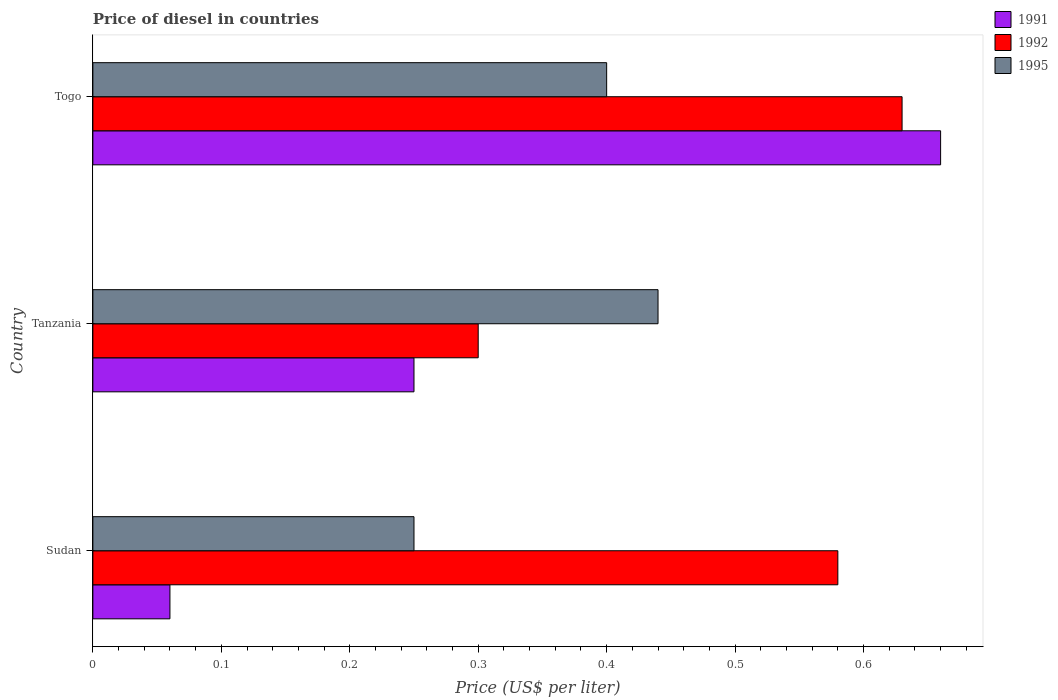What is the label of the 1st group of bars from the top?
Offer a very short reply. Togo. In how many cases, is the number of bars for a given country not equal to the number of legend labels?
Keep it short and to the point. 0. What is the price of diesel in 1992 in Sudan?
Give a very brief answer. 0.58. Across all countries, what is the maximum price of diesel in 1995?
Provide a short and direct response. 0.44. Across all countries, what is the minimum price of diesel in 1991?
Make the answer very short. 0.06. In which country was the price of diesel in 1992 maximum?
Ensure brevity in your answer.  Togo. In which country was the price of diesel in 1992 minimum?
Give a very brief answer. Tanzania. What is the total price of diesel in 1992 in the graph?
Make the answer very short. 1.51. What is the difference between the price of diesel in 1995 in Sudan and that in Togo?
Provide a short and direct response. -0.15. What is the difference between the price of diesel in 1995 in Sudan and the price of diesel in 1992 in Togo?
Provide a short and direct response. -0.38. What is the average price of diesel in 1991 per country?
Ensure brevity in your answer.  0.32. What is the difference between the price of diesel in 1991 and price of diesel in 1995 in Sudan?
Offer a terse response. -0.19. In how many countries, is the price of diesel in 1992 greater than 0.30000000000000004 US$?
Provide a succinct answer. 2. Is the price of diesel in 1992 in Sudan less than that in Togo?
Your answer should be very brief. Yes. Is the difference between the price of diesel in 1991 in Sudan and Togo greater than the difference between the price of diesel in 1995 in Sudan and Togo?
Keep it short and to the point. No. What is the difference between the highest and the second highest price of diesel in 1992?
Give a very brief answer. 0.05. What is the difference between the highest and the lowest price of diesel in 1995?
Your answer should be compact. 0.19. What does the 1st bar from the top in Togo represents?
Your response must be concise. 1995. How many bars are there?
Give a very brief answer. 9. Are the values on the major ticks of X-axis written in scientific E-notation?
Your response must be concise. No. Where does the legend appear in the graph?
Offer a terse response. Top right. How many legend labels are there?
Make the answer very short. 3. What is the title of the graph?
Provide a short and direct response. Price of diesel in countries. What is the label or title of the X-axis?
Make the answer very short. Price (US$ per liter). What is the Price (US$ per liter) in 1991 in Sudan?
Provide a short and direct response. 0.06. What is the Price (US$ per liter) in 1992 in Sudan?
Your answer should be very brief. 0.58. What is the Price (US$ per liter) of 1995 in Sudan?
Provide a succinct answer. 0.25. What is the Price (US$ per liter) in 1995 in Tanzania?
Keep it short and to the point. 0.44. What is the Price (US$ per liter) of 1991 in Togo?
Make the answer very short. 0.66. What is the Price (US$ per liter) of 1992 in Togo?
Keep it short and to the point. 0.63. What is the Price (US$ per liter) in 1995 in Togo?
Give a very brief answer. 0.4. Across all countries, what is the maximum Price (US$ per liter) in 1991?
Your answer should be very brief. 0.66. Across all countries, what is the maximum Price (US$ per liter) in 1992?
Your response must be concise. 0.63. Across all countries, what is the maximum Price (US$ per liter) of 1995?
Provide a succinct answer. 0.44. Across all countries, what is the minimum Price (US$ per liter) of 1991?
Your response must be concise. 0.06. What is the total Price (US$ per liter) in 1991 in the graph?
Give a very brief answer. 0.97. What is the total Price (US$ per liter) of 1992 in the graph?
Keep it short and to the point. 1.51. What is the total Price (US$ per liter) of 1995 in the graph?
Provide a short and direct response. 1.09. What is the difference between the Price (US$ per liter) of 1991 in Sudan and that in Tanzania?
Your answer should be compact. -0.19. What is the difference between the Price (US$ per liter) in 1992 in Sudan and that in Tanzania?
Provide a succinct answer. 0.28. What is the difference between the Price (US$ per liter) in 1995 in Sudan and that in Tanzania?
Your response must be concise. -0.19. What is the difference between the Price (US$ per liter) of 1992 in Sudan and that in Togo?
Your answer should be very brief. -0.05. What is the difference between the Price (US$ per liter) of 1991 in Tanzania and that in Togo?
Offer a very short reply. -0.41. What is the difference between the Price (US$ per liter) of 1992 in Tanzania and that in Togo?
Keep it short and to the point. -0.33. What is the difference between the Price (US$ per liter) in 1991 in Sudan and the Price (US$ per liter) in 1992 in Tanzania?
Give a very brief answer. -0.24. What is the difference between the Price (US$ per liter) of 1991 in Sudan and the Price (US$ per liter) of 1995 in Tanzania?
Your answer should be compact. -0.38. What is the difference between the Price (US$ per liter) of 1992 in Sudan and the Price (US$ per liter) of 1995 in Tanzania?
Make the answer very short. 0.14. What is the difference between the Price (US$ per liter) of 1991 in Sudan and the Price (US$ per liter) of 1992 in Togo?
Provide a short and direct response. -0.57. What is the difference between the Price (US$ per liter) of 1991 in Sudan and the Price (US$ per liter) of 1995 in Togo?
Your answer should be compact. -0.34. What is the difference between the Price (US$ per liter) in 1992 in Sudan and the Price (US$ per liter) in 1995 in Togo?
Offer a very short reply. 0.18. What is the difference between the Price (US$ per liter) of 1991 in Tanzania and the Price (US$ per liter) of 1992 in Togo?
Offer a very short reply. -0.38. What is the difference between the Price (US$ per liter) of 1992 in Tanzania and the Price (US$ per liter) of 1995 in Togo?
Ensure brevity in your answer.  -0.1. What is the average Price (US$ per liter) of 1991 per country?
Offer a very short reply. 0.32. What is the average Price (US$ per liter) of 1992 per country?
Give a very brief answer. 0.5. What is the average Price (US$ per liter) in 1995 per country?
Offer a very short reply. 0.36. What is the difference between the Price (US$ per liter) of 1991 and Price (US$ per liter) of 1992 in Sudan?
Your answer should be very brief. -0.52. What is the difference between the Price (US$ per liter) in 1991 and Price (US$ per liter) in 1995 in Sudan?
Your response must be concise. -0.19. What is the difference between the Price (US$ per liter) in 1992 and Price (US$ per liter) in 1995 in Sudan?
Your response must be concise. 0.33. What is the difference between the Price (US$ per liter) in 1991 and Price (US$ per liter) in 1992 in Tanzania?
Your response must be concise. -0.05. What is the difference between the Price (US$ per liter) in 1991 and Price (US$ per liter) in 1995 in Tanzania?
Your response must be concise. -0.19. What is the difference between the Price (US$ per liter) of 1992 and Price (US$ per liter) of 1995 in Tanzania?
Offer a very short reply. -0.14. What is the difference between the Price (US$ per liter) in 1991 and Price (US$ per liter) in 1995 in Togo?
Provide a short and direct response. 0.26. What is the difference between the Price (US$ per liter) of 1992 and Price (US$ per liter) of 1995 in Togo?
Make the answer very short. 0.23. What is the ratio of the Price (US$ per liter) in 1991 in Sudan to that in Tanzania?
Provide a short and direct response. 0.24. What is the ratio of the Price (US$ per liter) in 1992 in Sudan to that in Tanzania?
Ensure brevity in your answer.  1.93. What is the ratio of the Price (US$ per liter) in 1995 in Sudan to that in Tanzania?
Your answer should be very brief. 0.57. What is the ratio of the Price (US$ per liter) in 1991 in Sudan to that in Togo?
Provide a short and direct response. 0.09. What is the ratio of the Price (US$ per liter) in 1992 in Sudan to that in Togo?
Offer a very short reply. 0.92. What is the ratio of the Price (US$ per liter) of 1991 in Tanzania to that in Togo?
Offer a terse response. 0.38. What is the ratio of the Price (US$ per liter) in 1992 in Tanzania to that in Togo?
Make the answer very short. 0.48. What is the ratio of the Price (US$ per liter) in 1995 in Tanzania to that in Togo?
Give a very brief answer. 1.1. What is the difference between the highest and the second highest Price (US$ per liter) in 1991?
Provide a short and direct response. 0.41. What is the difference between the highest and the second highest Price (US$ per liter) in 1995?
Your answer should be very brief. 0.04. What is the difference between the highest and the lowest Price (US$ per liter) of 1992?
Ensure brevity in your answer.  0.33. What is the difference between the highest and the lowest Price (US$ per liter) of 1995?
Provide a succinct answer. 0.19. 